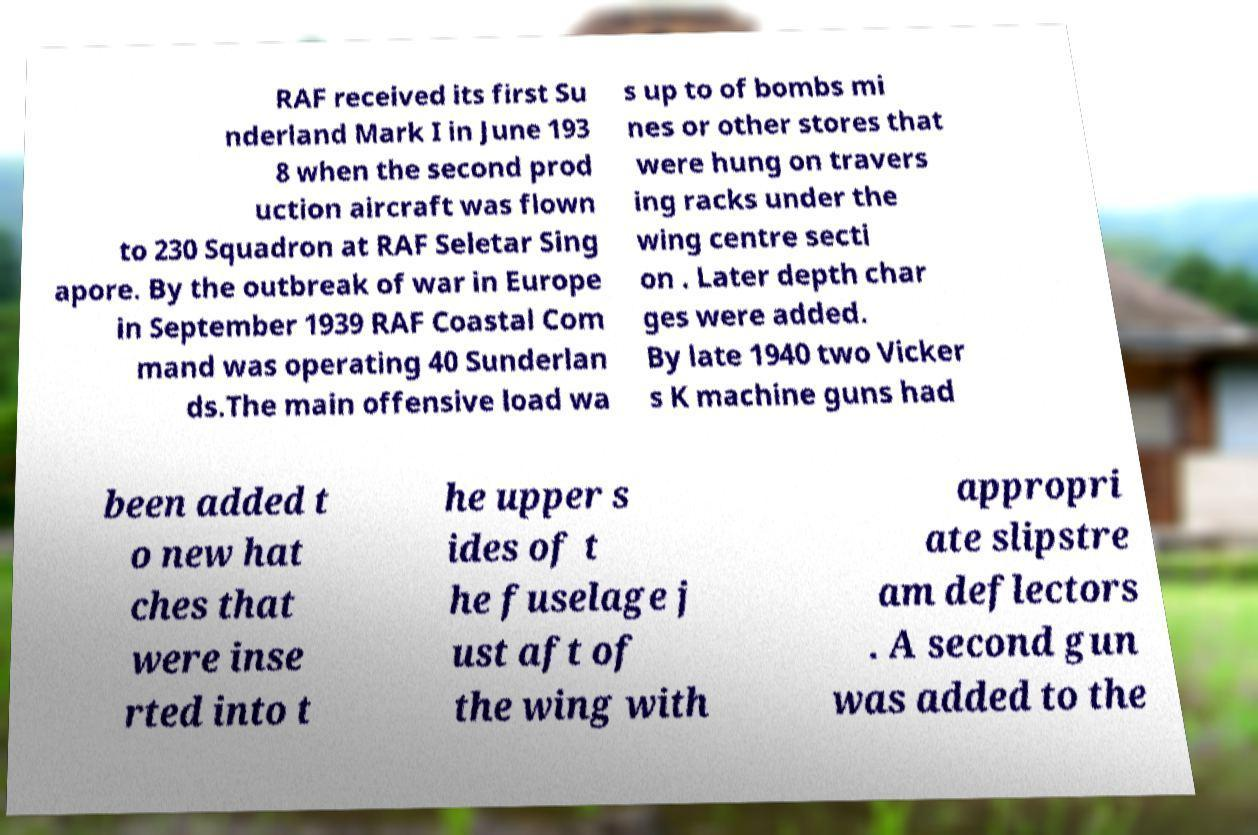What messages or text are displayed in this image? I need them in a readable, typed format. RAF received its first Su nderland Mark I in June 193 8 when the second prod uction aircraft was flown to 230 Squadron at RAF Seletar Sing apore. By the outbreak of war in Europe in September 1939 RAF Coastal Com mand was operating 40 Sunderlan ds.The main offensive load wa s up to of bombs mi nes or other stores that were hung on travers ing racks under the wing centre secti on . Later depth char ges were added. By late 1940 two Vicker s K machine guns had been added t o new hat ches that were inse rted into t he upper s ides of t he fuselage j ust aft of the wing with appropri ate slipstre am deflectors . A second gun was added to the 